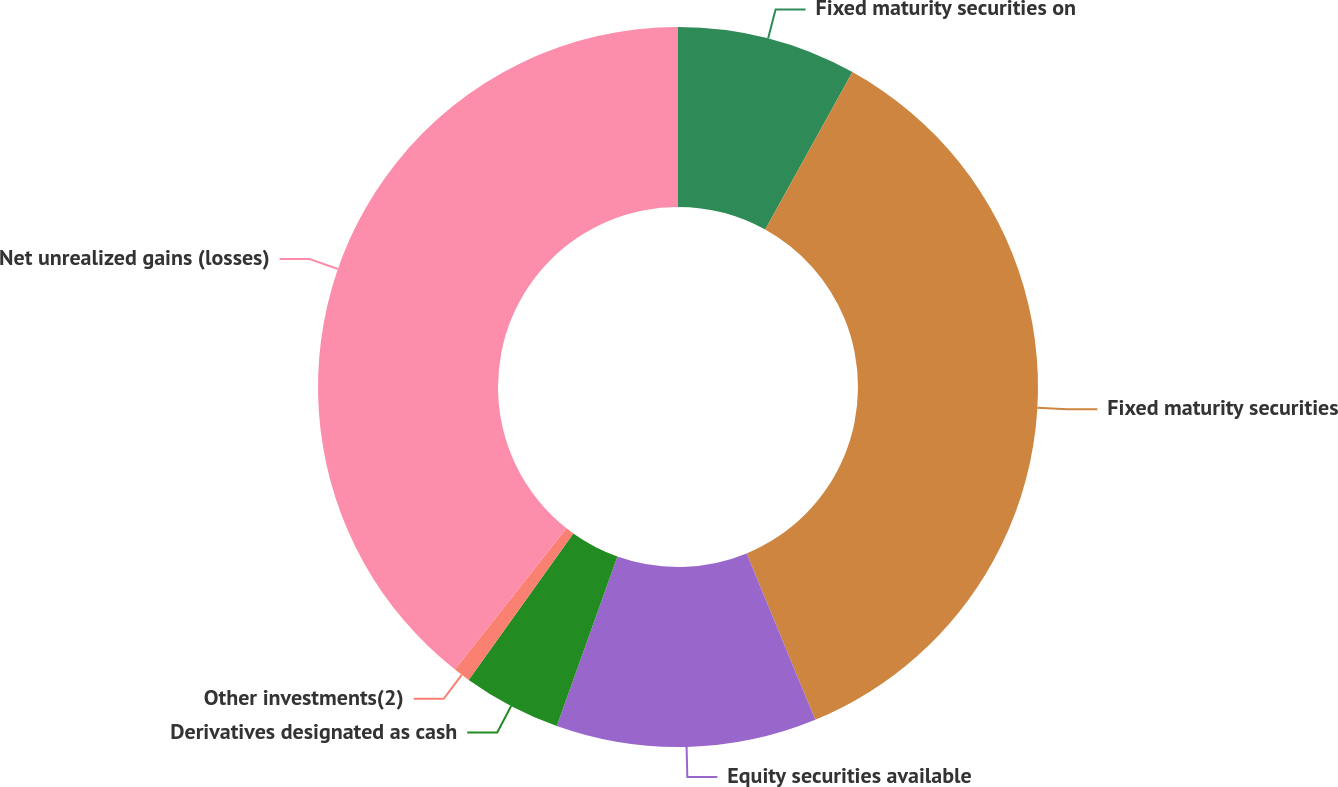Convert chart. <chart><loc_0><loc_0><loc_500><loc_500><pie_chart><fcel>Fixed maturity securities on<fcel>Fixed maturity securities<fcel>Equity securities available<fcel>Derivatives designated as cash<fcel>Other investments(2)<fcel>Net unrealized gains (losses)<nl><fcel>8.05%<fcel>35.72%<fcel>11.69%<fcel>4.41%<fcel>0.76%<fcel>39.36%<nl></chart> 